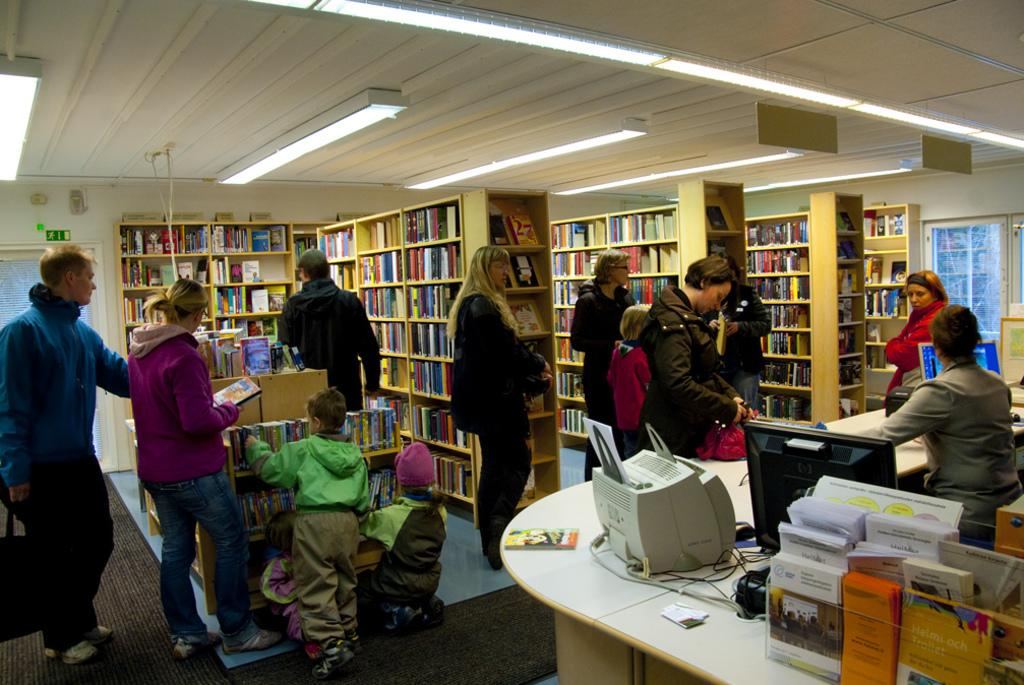How many people are the people are present in the image? There are people in the image, but the exact number is not specified. What can be found on the racks in the image? There are books on the racks in the image. What are the boards used for in the image? The boards are not described in detail, but they are present in the image. What type of lighting is visible in the image? There are lights in the image. What is the ceiling like in the image? There is a ceiling in the image. What can be seen on the monitors in the image? The content on the monitors is not specified. What are the boxes used for in the in the image? The purpose of the boxes is not described. What are the papers used for in the image? The purpose of the papers is not described. What are the cables connected to in the image? The cables are not described in detail, but they are present in the image. What is the table used for in the image? The purpose of the table is not described. Can you tell me how much cheese is on the table in the image? There is no cheese present in the image. What type of action is taking place in the image? The image does not depict any specific action or event. Is there a volcano visible in the image? There is no volcano present in the image. 